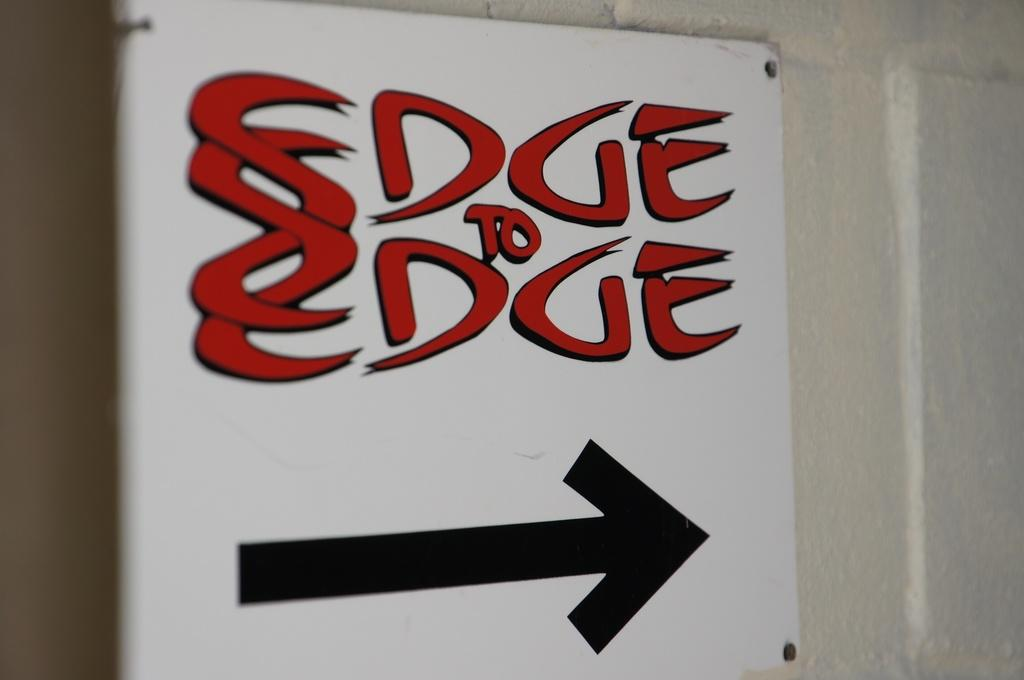<image>
Summarize the visual content of the image. A sign with an arrow points the way to Edge to Edge. 